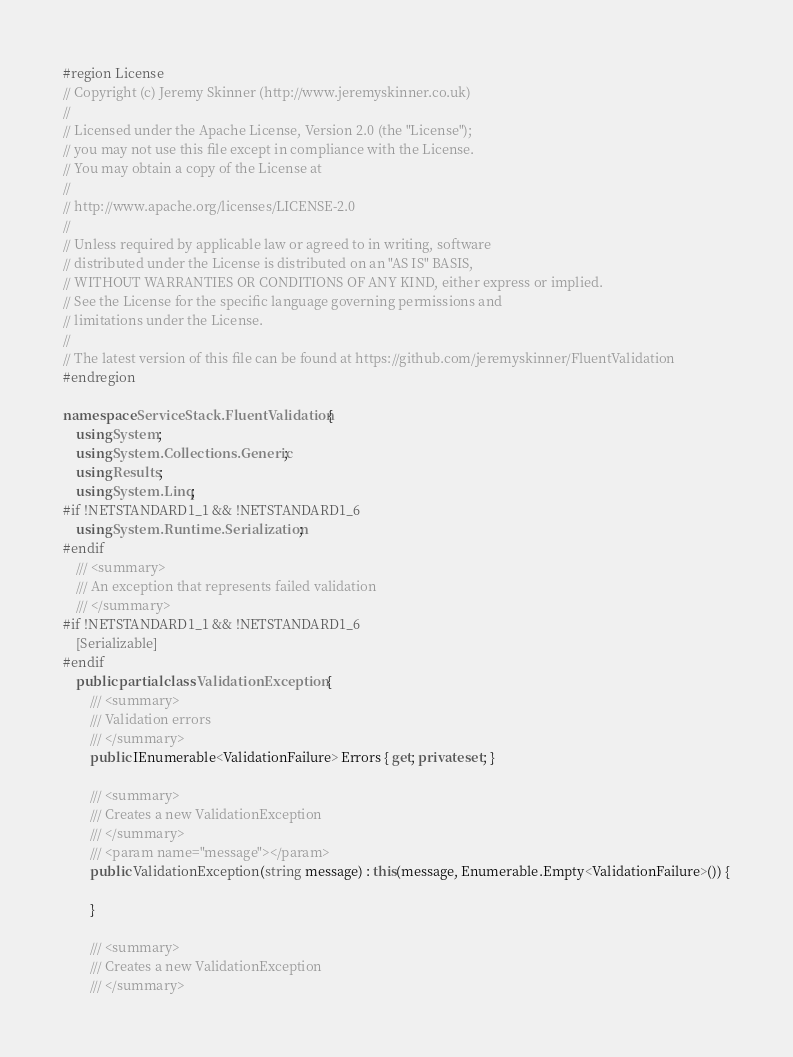Convert code to text. <code><loc_0><loc_0><loc_500><loc_500><_C#_>#region License
// Copyright (c) Jeremy Skinner (http://www.jeremyskinner.co.uk)
//
// Licensed under the Apache License, Version 2.0 (the "License");
// you may not use this file except in compliance with the License.
// You may obtain a copy of the License at
//
// http://www.apache.org/licenses/LICENSE-2.0
//
// Unless required by applicable law or agreed to in writing, software
// distributed under the License is distributed on an "AS IS" BASIS,
// WITHOUT WARRANTIES OR CONDITIONS OF ANY KIND, either express or implied.
// See the License for the specific language governing permissions and
// limitations under the License.
//
// The latest version of this file can be found at https://github.com/jeremyskinner/FluentValidation
#endregion

namespace ServiceStack.FluentValidation {
	using System;
	using System.Collections.Generic;
	using Results;
	using System.Linq;
#if !NETSTANDARD1_1 && !NETSTANDARD1_6
	using System.Runtime.Serialization;
#endif
	/// <summary>
	/// An exception that represents failed validation
	/// </summary>
#if !NETSTANDARD1_1 && !NETSTANDARD1_6
	[Serializable]
#endif
	public partial class ValidationException {
		/// <summary>
		/// Validation errors
		/// </summary>
		public IEnumerable<ValidationFailure> Errors { get; private set; }

		/// <summary>
		/// Creates a new ValidationException
		/// </summary>
		/// <param name="message"></param>
	    public ValidationException(string message) : this(message, Enumerable.Empty<ValidationFailure>()) {

	    }

		/// <summary>
		/// Creates a new ValidationException
		/// </summary></code> 